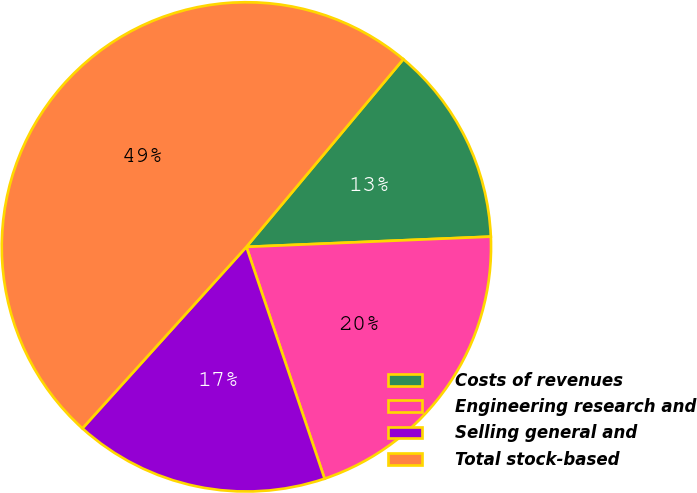<chart> <loc_0><loc_0><loc_500><loc_500><pie_chart><fcel>Costs of revenues<fcel>Engineering research and<fcel>Selling general and<fcel>Total stock-based<nl><fcel>13.25%<fcel>20.49%<fcel>16.87%<fcel>49.39%<nl></chart> 